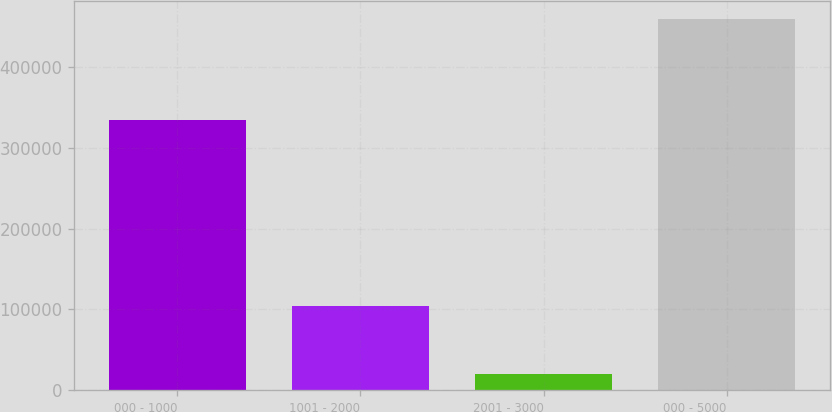<chart> <loc_0><loc_0><loc_500><loc_500><bar_chart><fcel>000 - 1000<fcel>1001 - 2000<fcel>2001 - 3000<fcel>000 - 5000<nl><fcel>334741<fcel>104702<fcel>19819<fcel>459262<nl></chart> 